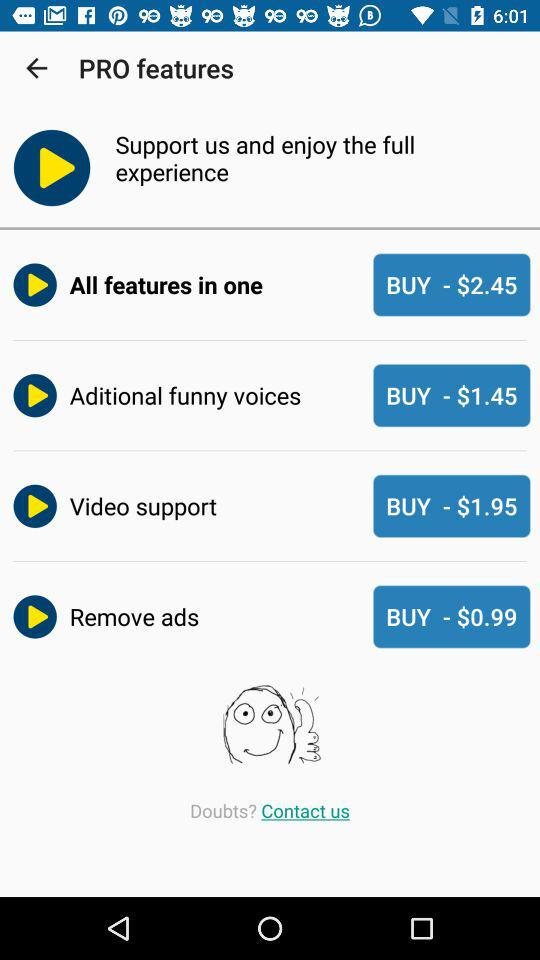What is the version of this application?
When the provided information is insufficient, respond with <no answer>. <no answer> 